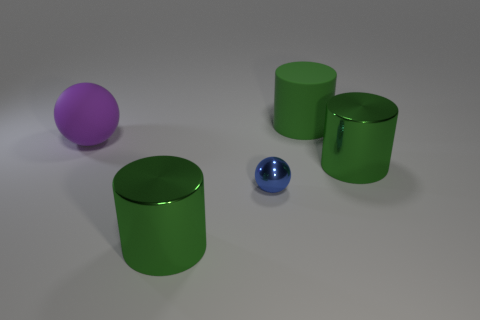There is another matte object that is the same size as the purple thing; what is its shape?
Ensure brevity in your answer.  Cylinder. Are there fewer blue spheres than tiny cyan objects?
Your response must be concise. No. What number of blue metallic objects have the same size as the purple object?
Provide a short and direct response. 0. What material is the small thing?
Offer a terse response. Metal. There is a green metal thing that is on the right side of the green rubber cylinder; how big is it?
Provide a short and direct response. Large. What number of other tiny objects have the same shape as the purple object?
Offer a terse response. 1. What shape is the large object that is made of the same material as the big purple sphere?
Your response must be concise. Cylinder. What number of green objects are tiny metal balls or large metallic things?
Offer a terse response. 2. There is a blue shiny ball; are there any large metallic cylinders in front of it?
Give a very brief answer. Yes. Does the big matte object to the right of the large purple matte sphere have the same shape as the metallic thing that is on the right side of the blue ball?
Keep it short and to the point. Yes. 